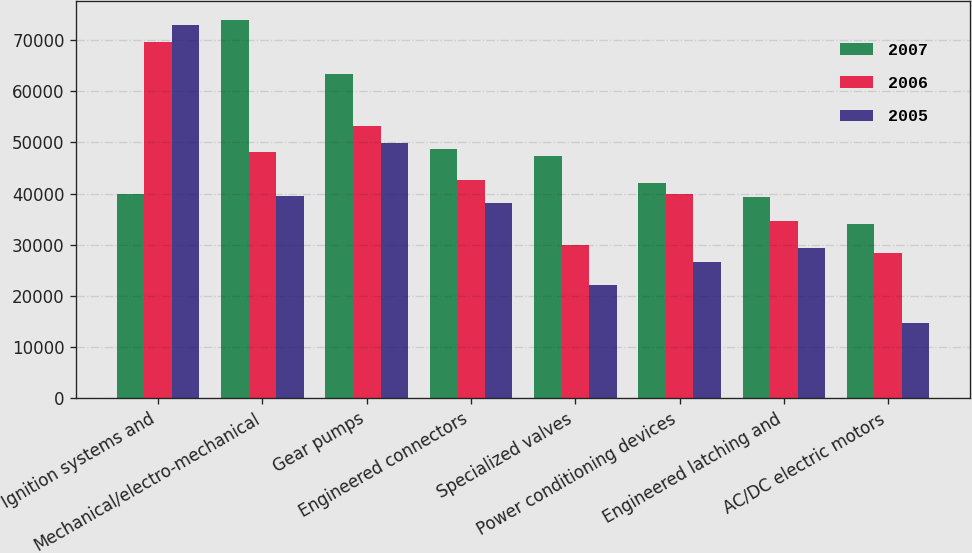<chart> <loc_0><loc_0><loc_500><loc_500><stacked_bar_chart><ecel><fcel>Ignition systems and<fcel>Mechanical/electro-mechanical<fcel>Gear pumps<fcel>Engineered connectors<fcel>Specialized valves<fcel>Power conditioning devices<fcel>Engineered latching and<fcel>AC/DC electric motors<nl><fcel>2007<fcel>39878<fcel>73940<fcel>63275<fcel>48773<fcel>47434<fcel>42048<fcel>39360<fcel>34075<nl><fcel>2006<fcel>69533<fcel>48049<fcel>53206<fcel>42578<fcel>29880<fcel>39878<fcel>34676<fcel>28411<nl><fcel>2005<fcel>72902<fcel>39457<fcel>49787<fcel>38065<fcel>22204<fcel>26612<fcel>29368<fcel>14654<nl></chart> 